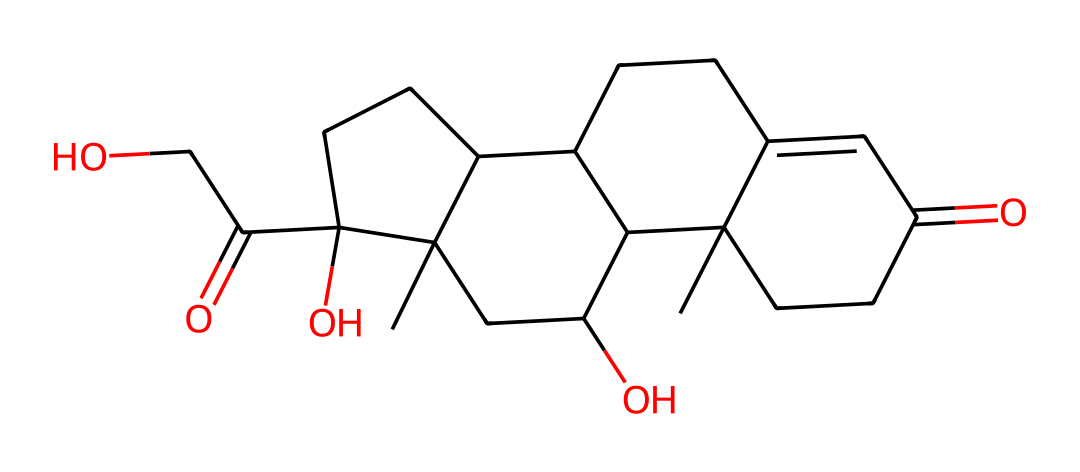What is the molecular formula of cortisol? By analyzing the SMILES representation, we can identify the individual carbon (C), hydrogen (H), and oxygen (O) atoms. Counting the atoms from the structure gives us the molecular formula C21H30O5.
Answer: C21H30O5 How many rings are present in the structure? The SMILES notation indicates that there are several cyclical structures present. Looking closely, we can count three distinct rings in the chemical structure of cortisol.
Answer: 3 What functional group is present in the molecular structure? The SMILES representation includes a carbonyl group (C=O) and a hydroxyl group (–OH). Identifying these functional groups shows that cortisol contains both ketone and alcohol functional groups.
Answer: ketone and alcohol Which part of cortisol is primarily responsible for its stress-related functions? Cortisol is a steroid hormone, and its effects are mediated largely by its receptor interactions, which can be traced back to the presence of its steroidal backbone within the molecular structure, particularly in its A and B rings.
Answer: steroidal backbone Does cortisol have any stereocenters? By examining the structure and checking for chiral centers, we find that cortisol has four stereocenters based on the arrangement of groups around specific carbon atoms.
Answer: 4 What is the general class of this chemical? Cortisol is classified as a steroid, which can be concluded from its characteristic structure composed of four fused carbon rings, typical for steroids.
Answer: steroid 